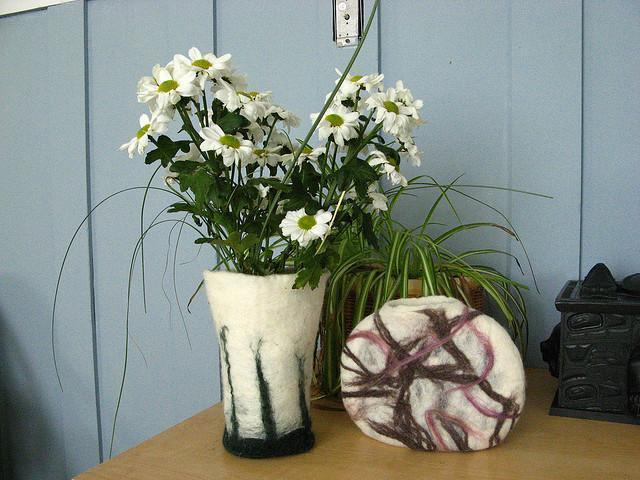How many vases are visible?
Give a very brief answer. 2. How many dining tables are there?
Give a very brief answer. 1. 